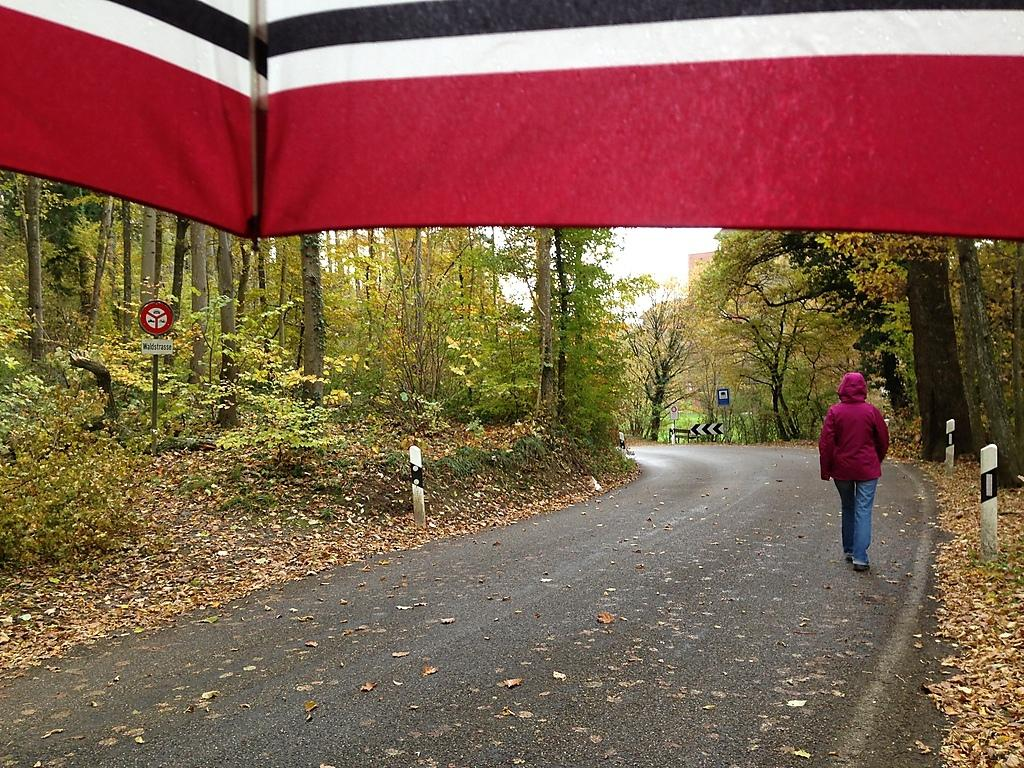What is the person in the image doing? There is a person walking on the road in the image. What object is being used to protect from the elements in the image? There is an umbrella visible in the image. What can be seen behind the umbrella in the image? There are trees behind the umbrella in the image. What structures are present in the image? There are poles in the image. What type of information might be conveyed by the sign boards in the image? There are sign boards in the image, which might convey information such as directions, warnings, or advertisements. What type of prison can be seen in the image? There is no prison present in the image. How many worms are crawling on the person walking in the image? There are no worms visible in the image. 